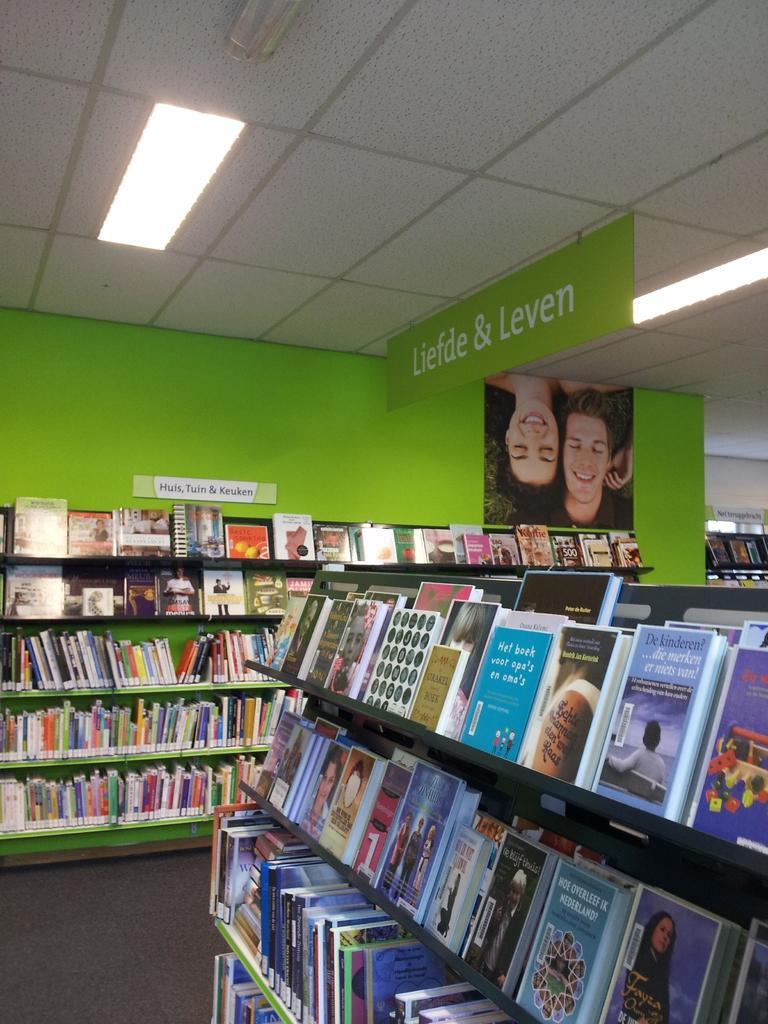Can you describe this image briefly? In this picture we can see the inside view of a building. There are books in the racks and there are two boards attached to a wall. At the top of the image, there are ceiling lights and a board. 